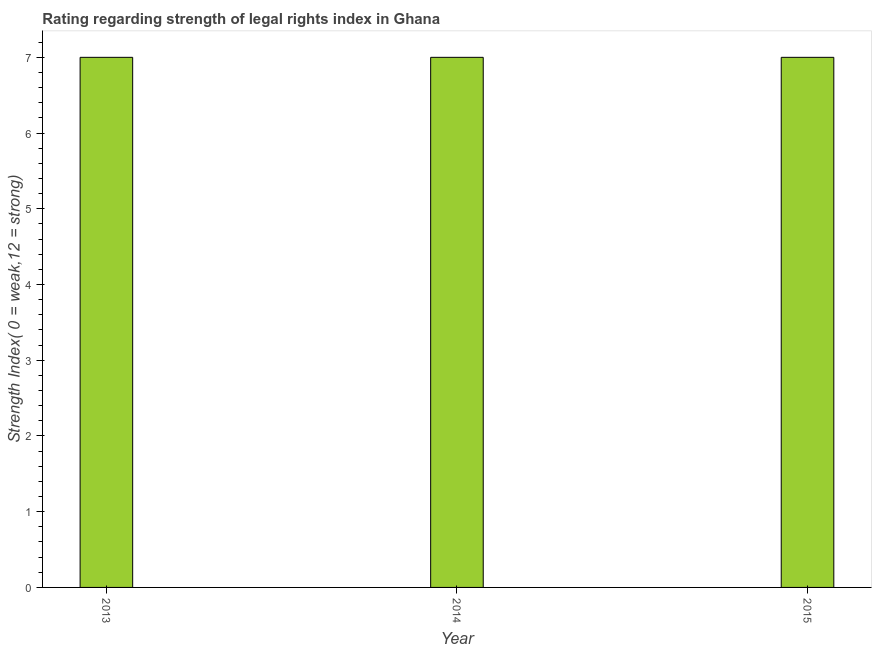What is the title of the graph?
Your answer should be compact. Rating regarding strength of legal rights index in Ghana. What is the label or title of the Y-axis?
Provide a succinct answer. Strength Index( 0 = weak,12 = strong). Across all years, what is the minimum strength of legal rights index?
Your answer should be very brief. 7. In which year was the strength of legal rights index maximum?
Ensure brevity in your answer.  2013. In which year was the strength of legal rights index minimum?
Give a very brief answer. 2013. What is the sum of the strength of legal rights index?
Offer a terse response. 21. What is the average strength of legal rights index per year?
Your response must be concise. 7. What is the median strength of legal rights index?
Provide a succinct answer. 7. In how many years, is the strength of legal rights index greater than 1.8 ?
Make the answer very short. 3. What is the ratio of the strength of legal rights index in 2014 to that in 2015?
Provide a succinct answer. 1. Is the difference between the strength of legal rights index in 2013 and 2015 greater than the difference between any two years?
Your response must be concise. Yes. Is the sum of the strength of legal rights index in 2013 and 2015 greater than the maximum strength of legal rights index across all years?
Your answer should be compact. Yes. In how many years, is the strength of legal rights index greater than the average strength of legal rights index taken over all years?
Provide a succinct answer. 0. Are all the bars in the graph horizontal?
Offer a very short reply. No. How many years are there in the graph?
Your answer should be compact. 3. What is the difference between two consecutive major ticks on the Y-axis?
Keep it short and to the point. 1. What is the Strength Index( 0 = weak,12 = strong) in 2015?
Keep it short and to the point. 7. What is the difference between the Strength Index( 0 = weak,12 = strong) in 2013 and 2014?
Your response must be concise. 0. What is the difference between the Strength Index( 0 = weak,12 = strong) in 2013 and 2015?
Offer a very short reply. 0. What is the ratio of the Strength Index( 0 = weak,12 = strong) in 2013 to that in 2014?
Make the answer very short. 1. What is the ratio of the Strength Index( 0 = weak,12 = strong) in 2013 to that in 2015?
Provide a short and direct response. 1. What is the ratio of the Strength Index( 0 = weak,12 = strong) in 2014 to that in 2015?
Offer a terse response. 1. 